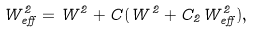<formula> <loc_0><loc_0><loc_500><loc_500>W _ { e f f } ^ { 2 } = W ^ { 2 } + C ( W ^ { 2 } + C _ { 2 } W _ { e f f } ^ { 2 } ) ,</formula> 